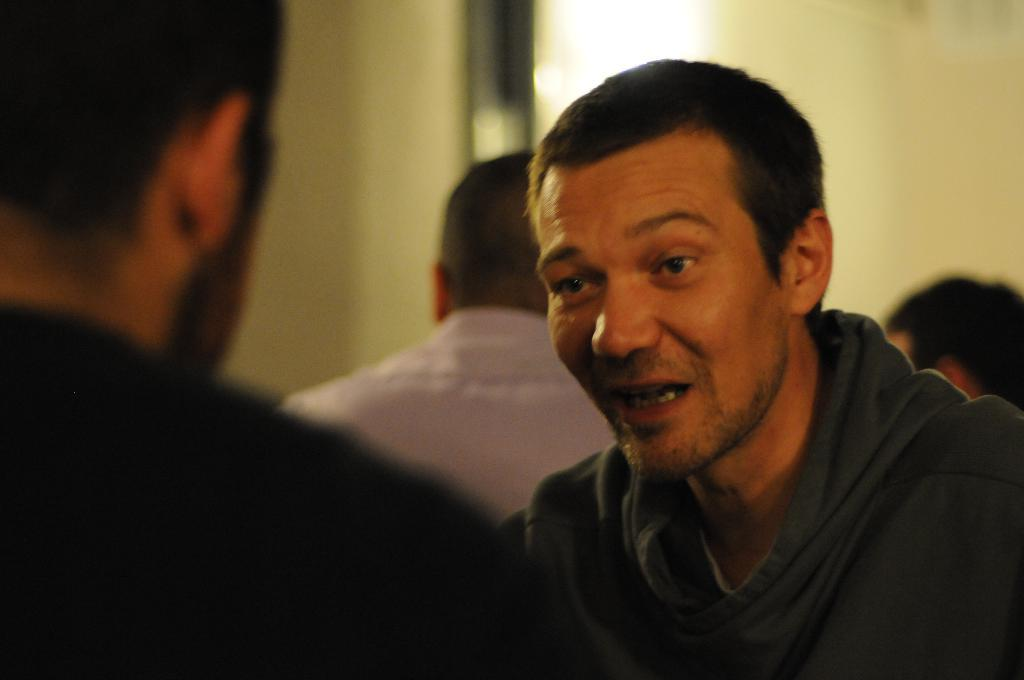What is the person on the right side of the image doing? The person is talking. What can be observed about the left side of the image? The left side of the image is blurred. What is happening in the background of the image? There are people sitting in the background, and there is a wall. What type of beast is sitting next to the queen in the image? There is no beast or queen present in the image. 